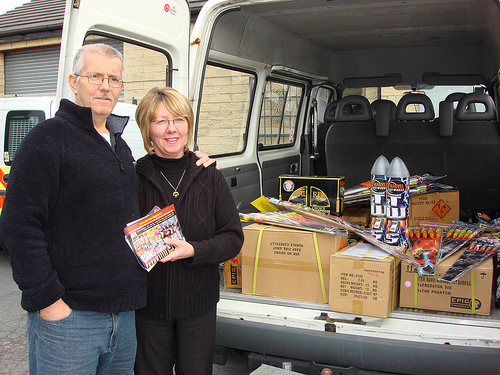<image>
Can you confirm if the pants is on the box? No. The pants is not positioned on the box. They may be near each other, but the pants is not supported by or resting on top of the box. Where is the box in relation to the man? Is it in front of the man? No. The box is not in front of the man. The spatial positioning shows a different relationship between these objects. 